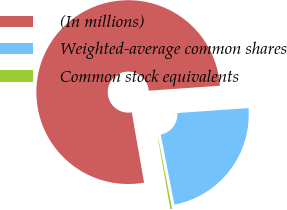<chart> <loc_0><loc_0><loc_500><loc_500><pie_chart><fcel>(In millions)<fcel>Weighted-average common shares<fcel>Common stock equivalents<nl><fcel>76.65%<fcel>23.04%<fcel>0.31%<nl></chart> 